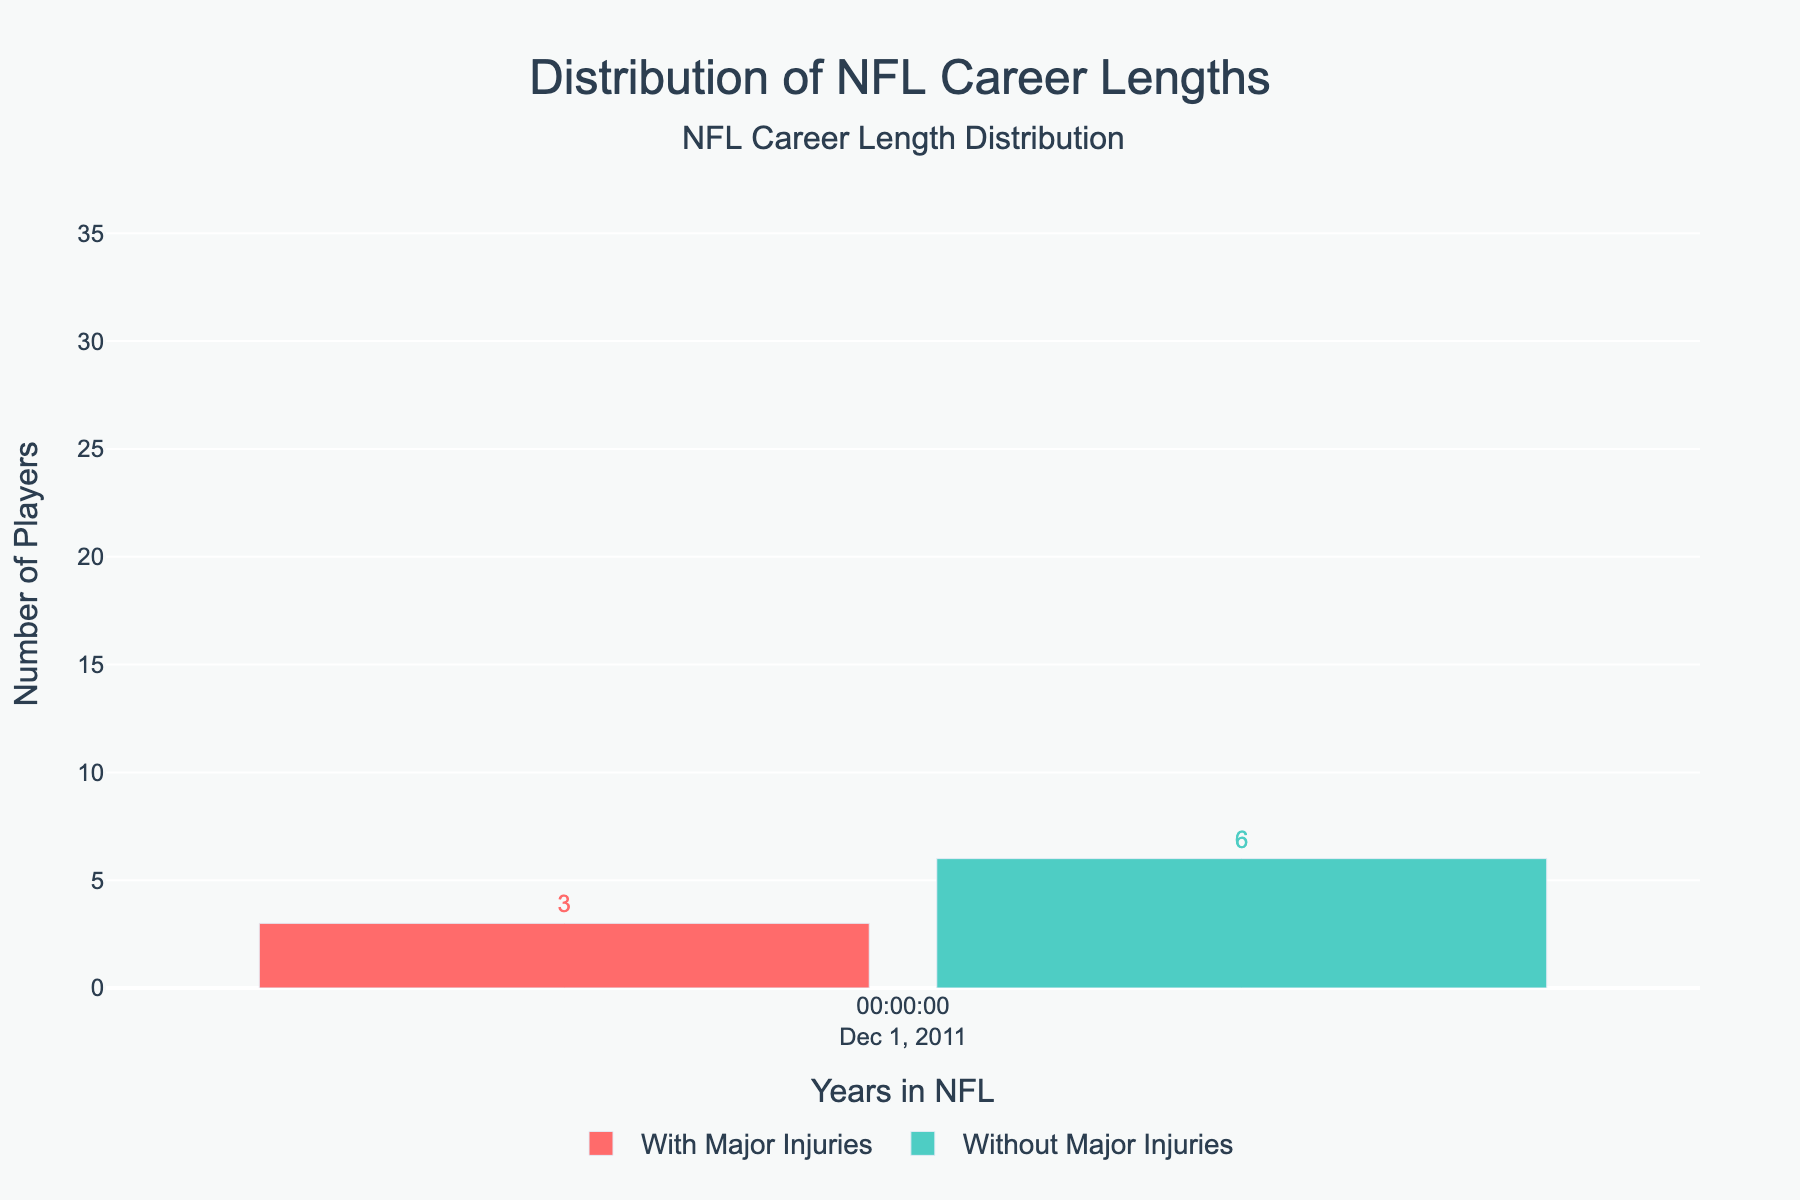How many more players without major injuries have NFL careers of 5-6 years compared to players with major injuries? Subtract the number of players with 5-6 year careers with major injuries from those without major injuries: 26 - 22 = 4
Answer: 4 Which career length has the highest number of players with major injuries, and what is that number? The bar representing 1-2 years has the highest height among the red bars, which is 32
Answer: 1-2 years, 32 What is the percentage difference in the number of players with 9-10 years in the NFL between those with major injuries and those without? Subtract the number with major injuries from those without and divide by the number with major injuries: (10 - 6) / 6 ≈ 0.67, then multiply by 100 to get the percentage ≈ 67%
Answer: 67% How many players have NFL careers of 7-8 years, considering both categories? Add the number of players with 7-8 years in both categories: 12 (with major injuries) + 18 (without major injuries) = 30
Answer: 30 Are there more players without major injuries in any career length category than the combined total of players with major injuries in the 1-2 and 3-4 year categories? Sum the players with major injuries in the 1-2 and 3-4 year categories: 32 + 28 = 60. Check if any single value in the "Without Major Injuries" column exceeds 60. No single value does.
Answer: No Which category has a more consistent number of players across the career lengths, with or without major injuries? The "Without Major Injuries" bars appear slightly more consistent across career lengths compared to the more fluctuating heights in the "With Major Injuries" bars.
Answer: Without Major Injuries 